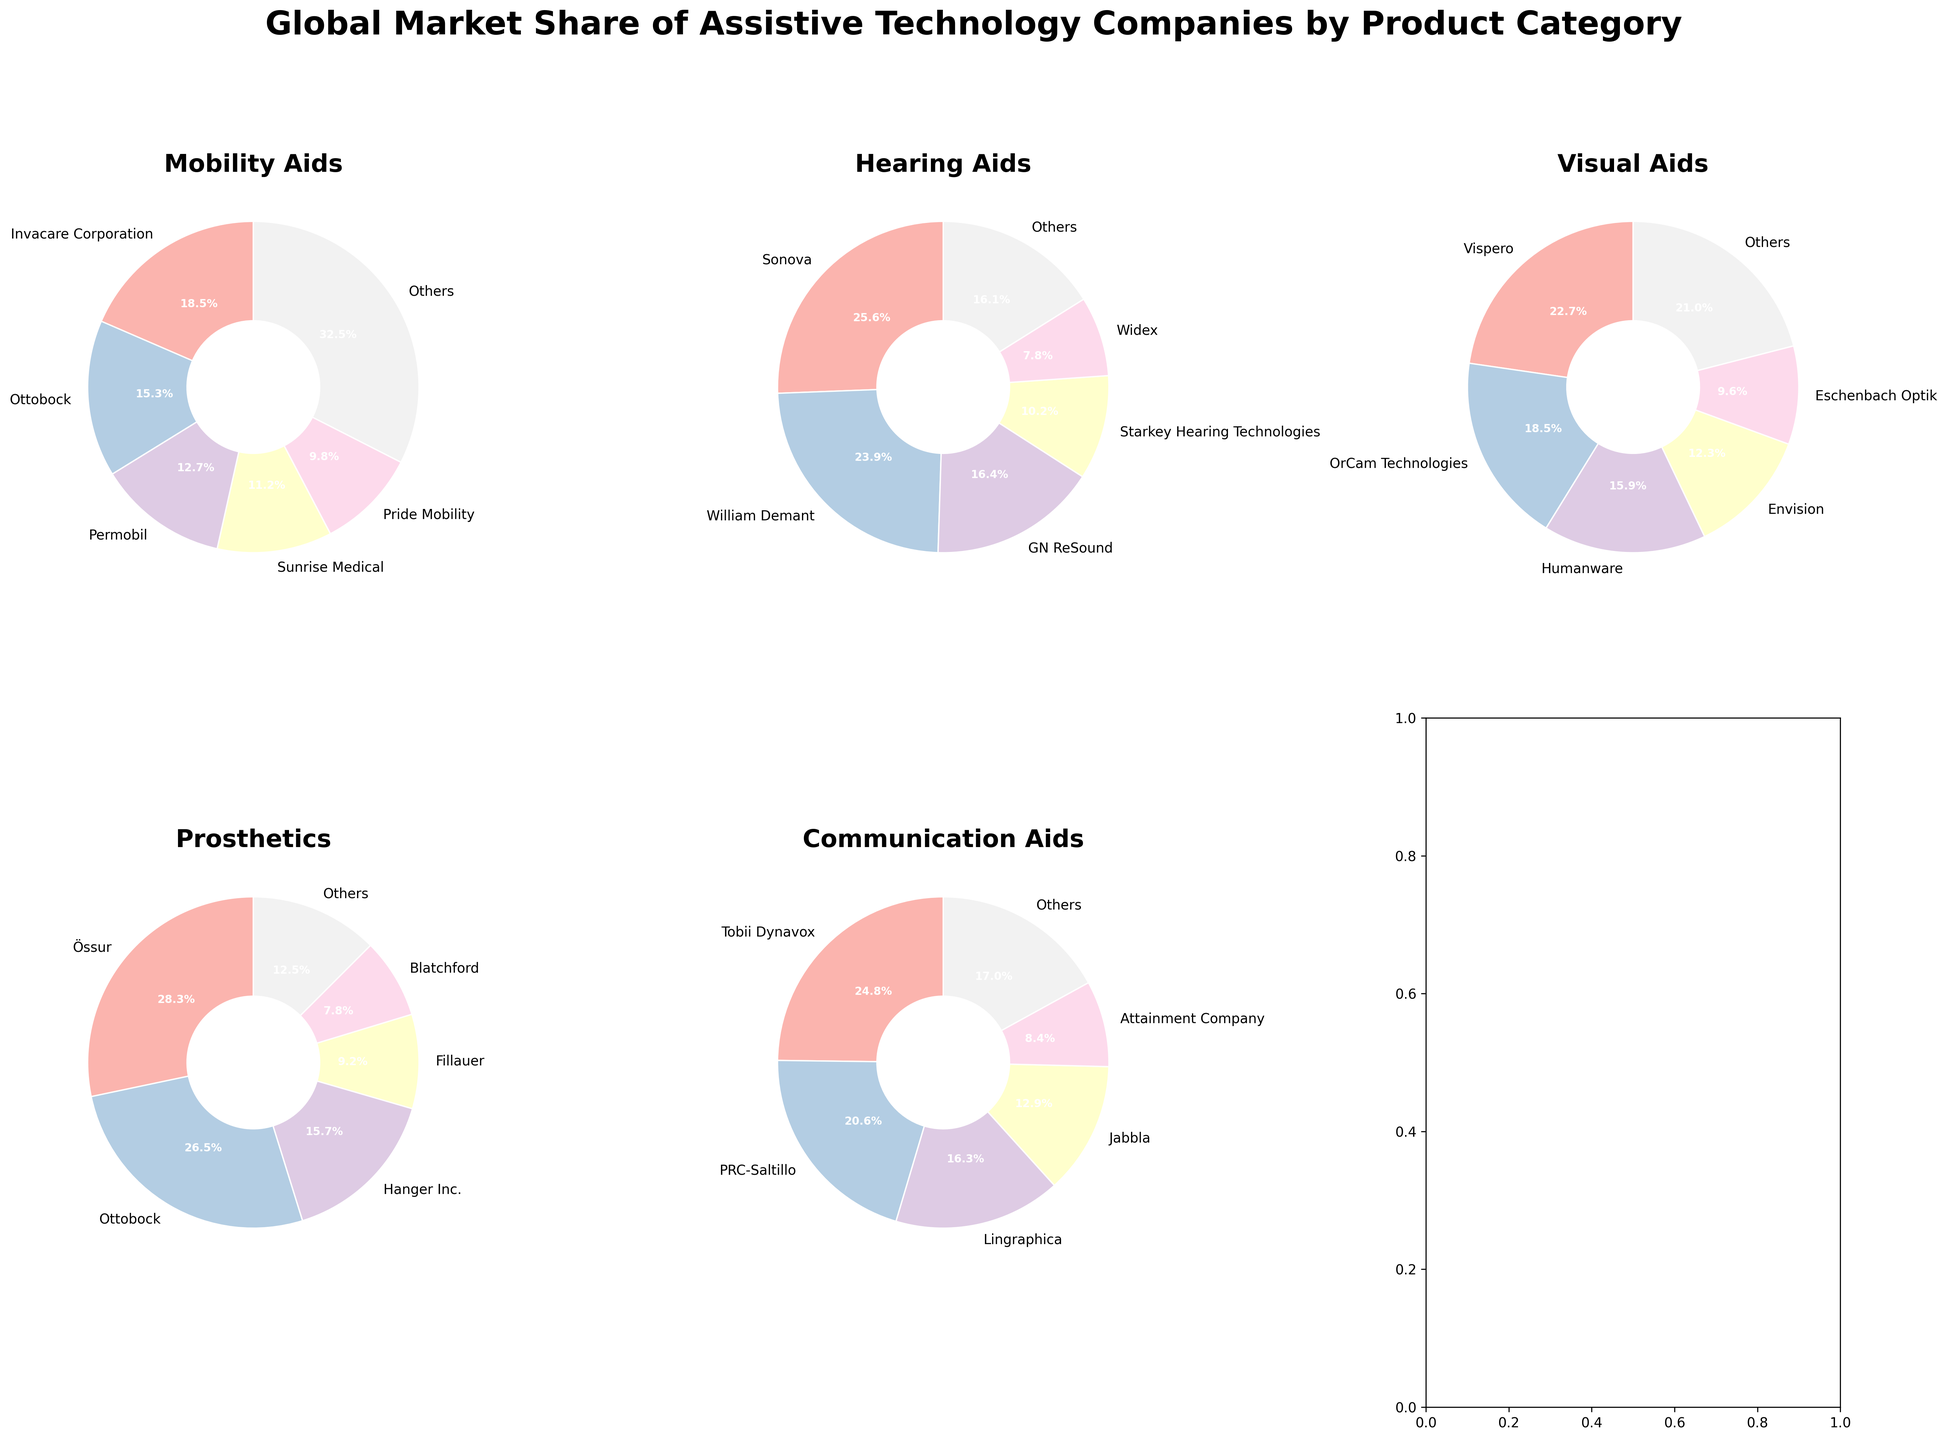What is the market share of the top company in the Mobility Aids category? By looking at the pie chart for the Mobility Aids category, find the largest segment. The label should indicate the top company and its market share.
Answer: 18.5% Compare the market shares of Sonova and Widex in the Hearing Aids category. Which company has a greater share? Check the pie chart for the Hearing Aids category and look at the segments labeled Sonova and Widex. Compare their market share percentages.
Answer: Sonova What is the total market share of the 'Others' category in all product categories? Sum the market share percentages labeled 'Others' in each product category pie chart.
Answer: 99.1% In the Prosthetics category, which company ranks second in terms of market share and what is its percentage? Check the pie chart for the Prosthetics category and find the segment with the second highest market share.
Answer: Ottobock, 26.5% Which product category has the smallest market share percentage for the 'Others' category? Compare the 'Others' segment in all pie charts and find the one with the smallest percentage.
Answer: Prosthetics What is the combined market share of Invacare Corporation and Ottobock in the Mobility Aids category? Add the market shares of Invacare Corporation (18.5%) and Ottobock (15.3%) from the Mobility Aids pie chart.
Answer: 33.8% How does the market share of Tobii Dynavox in Communication Aids compare to that of Vispero in Visual Aids? Find the segments for Tobii Dynavox in the Communication Aids chart and Vispero in the Visual Aids chart. Compare their percentages.
Answer: Tobii Dynavox has a higher market share Identify the company with the third highest market share in the Visual Aids category. Check the pie chart for Visual Aids and find the third largest segment by market share.
Answer: Humanware Which product category has the highest total market share of the top three companies combined? For each product category, add the market shares of the top three companies and compare the totals across categories.
Answer: Hearing Aids What is the difference in market share between Permobil and Pride Mobility in the Mobility Aids category? Subtract the market share of Pride Mobility (9.8%) from Permobil (12.7%) found in the Mobility Aids chart.
Answer: 2.9% 